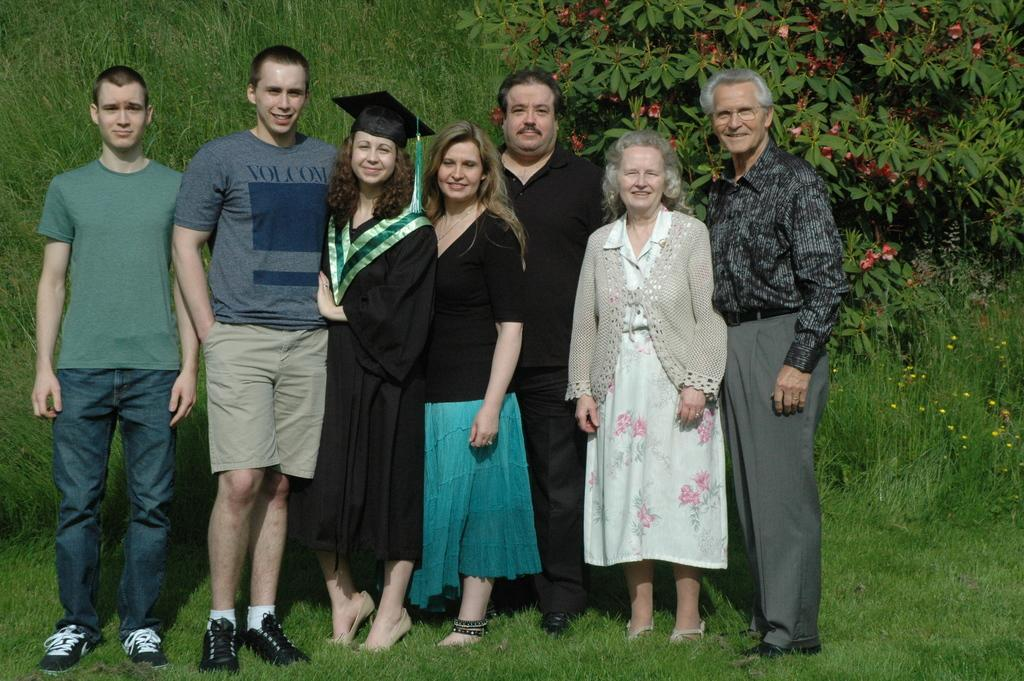How many people are in the group that is visible in the image? There is a group of people in the image, but the exact number is not specified. What is the facial expression of some people in the group? Some people in the group are smiling. What type of vegetation can be seen in the background of the image? There are plants, grass, and trees visible in the background of the image. What type of tank is visible in the image? There is no tank present in the image. What system is responsible for the growth of the plants in the image? The image does not provide information about the system responsible for the growth of the plants. 